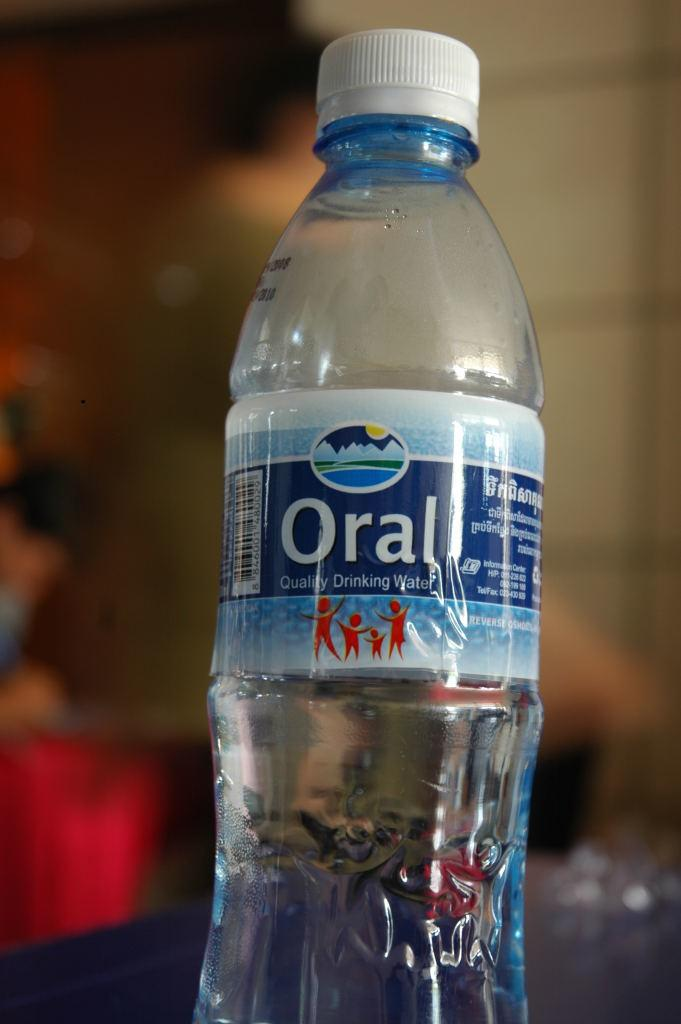What object is present in the image? There is a water bottle in the image. What is on the water bottle? The water bottle has a sticker on it. What color is the cap of the water bottle? The cap of the water bottle is white. What can be seen behind the water bottle? There is a blue background behind the water bottle. How many geese are flying in the image? There are no geese present in the image. What type of advice is given on the water bottle's sticker? There is no advice present on the water bottle's sticker; it only has a design or text related to the brand or product. 